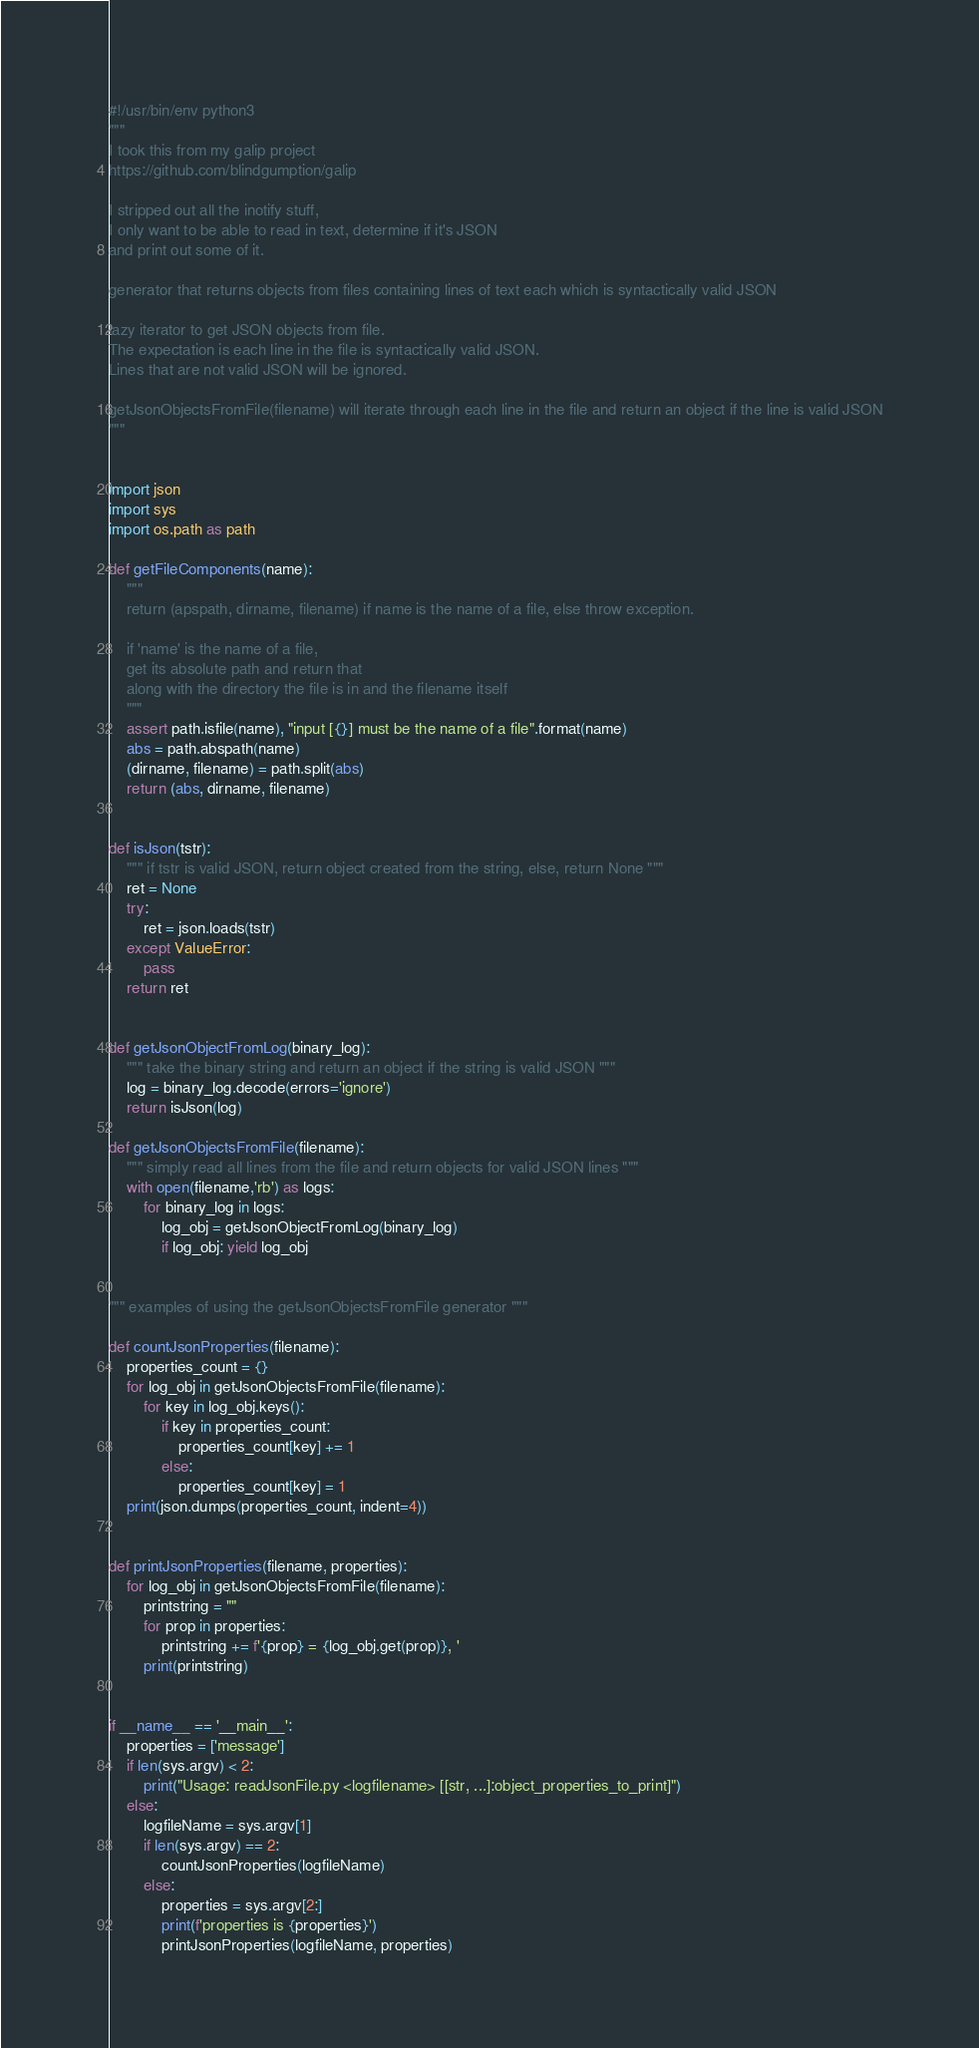Convert code to text. <code><loc_0><loc_0><loc_500><loc_500><_Python_>#!/usr/bin/env python3
""" 
I took this from my galip project
https://github.com/blindgumption/galip

I stripped out all the inotify stuff,
I only want to be able to read in text, determine if it's JSON 
and print out some of it.

generator that returns objects from files containing lines of text each which is syntactically valid JSON

lazy iterator to get JSON objects from file.
The expectation is each line in the file is syntactically valid JSON.
Lines that are not valid JSON will be ignored.

getJsonObjectsFromFile(filename) will iterate through each line in the file and return an object if the line is valid JSON
"""


import json
import sys 
import os.path as path 

def getFileComponents(name):
    """
    return (apspath, dirname, filename) if name is the name of a file, else throw exception.

    if 'name' is the name of a file, 
    get its absolute path and return that 
    along with the directory the file is in and the filename itself 
    """
    assert path.isfile(name), "input [{}] must be the name of a file".format(name)
    abs = path.abspath(name)
    (dirname, filename) = path.split(abs)
    return (abs, dirname, filename)


def isJson(tstr):
    """ if tstr is valid JSON, return object created from the string, else, return None """ 
    ret = None
    try:
        ret = json.loads(tstr)
    except ValueError:
        pass
    return ret


def getJsonObjectFromLog(binary_log):
    """ take the binary string and return an object if the string is valid JSON """ 
    log = binary_log.decode(errors='ignore')
    return isJson(log)

def getJsonObjectsFromFile(filename):
    """ simply read all lines from the file and return objects for valid JSON lines """ 
    with open(filename,'rb') as logs:
        for binary_log in logs:
            log_obj = getJsonObjectFromLog(binary_log)
            if log_obj: yield log_obj


""" examples of using the getJsonObjectsFromFile generator """ 

def countJsonProperties(filename):
    properties_count = {}
    for log_obj in getJsonObjectsFromFile(filename):
        for key in log_obj.keys():
            if key in properties_count:
                properties_count[key] += 1
            else:
                properties_count[key] = 1 
    print(json.dumps(properties_count, indent=4))


def printJsonProperties(filename, properties):
    for log_obj in getJsonObjectsFromFile(filename):
        printstring = ""
        for prop in properties:
            printstring += f'{prop} = {log_obj.get(prop)}, '
        print(printstring)


if __name__ == '__main__':
    properties = ['message']
    if len(sys.argv) < 2:
        print("Usage: readJsonFile.py <logfilename> [[str, ...]:object_properties_to_print]")
    else:
        logfileName = sys.argv[1]
        if len(sys.argv) == 2: 
            countJsonProperties(logfileName)
        else:
            properties = sys.argv[2:]
            print(f'properties is {properties}')
            printJsonProperties(logfileName, properties)
</code> 